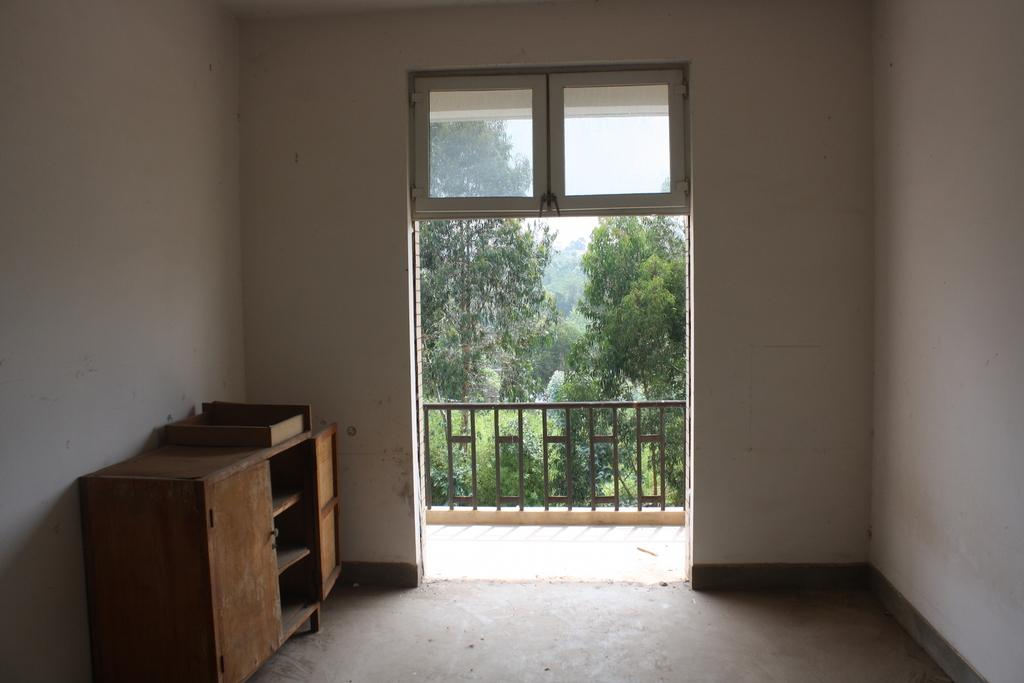What type of furniture is on the left side of the image? There is a wooden desk on the left side of the image. What can be seen through the window in the image? There are plants visible outside the window. What architectural feature is present in the image? There is a door in the image. Can you describe the natural elements visible in the image? The plants visible outside the window suggest a natural setting. What type of gold ornament is hanging on the door in the image? There is no gold ornament present on the door in the image. Can you describe the mountain range visible outside the window? There is no mountain range visible outside the window in the image; only plants are visible. 